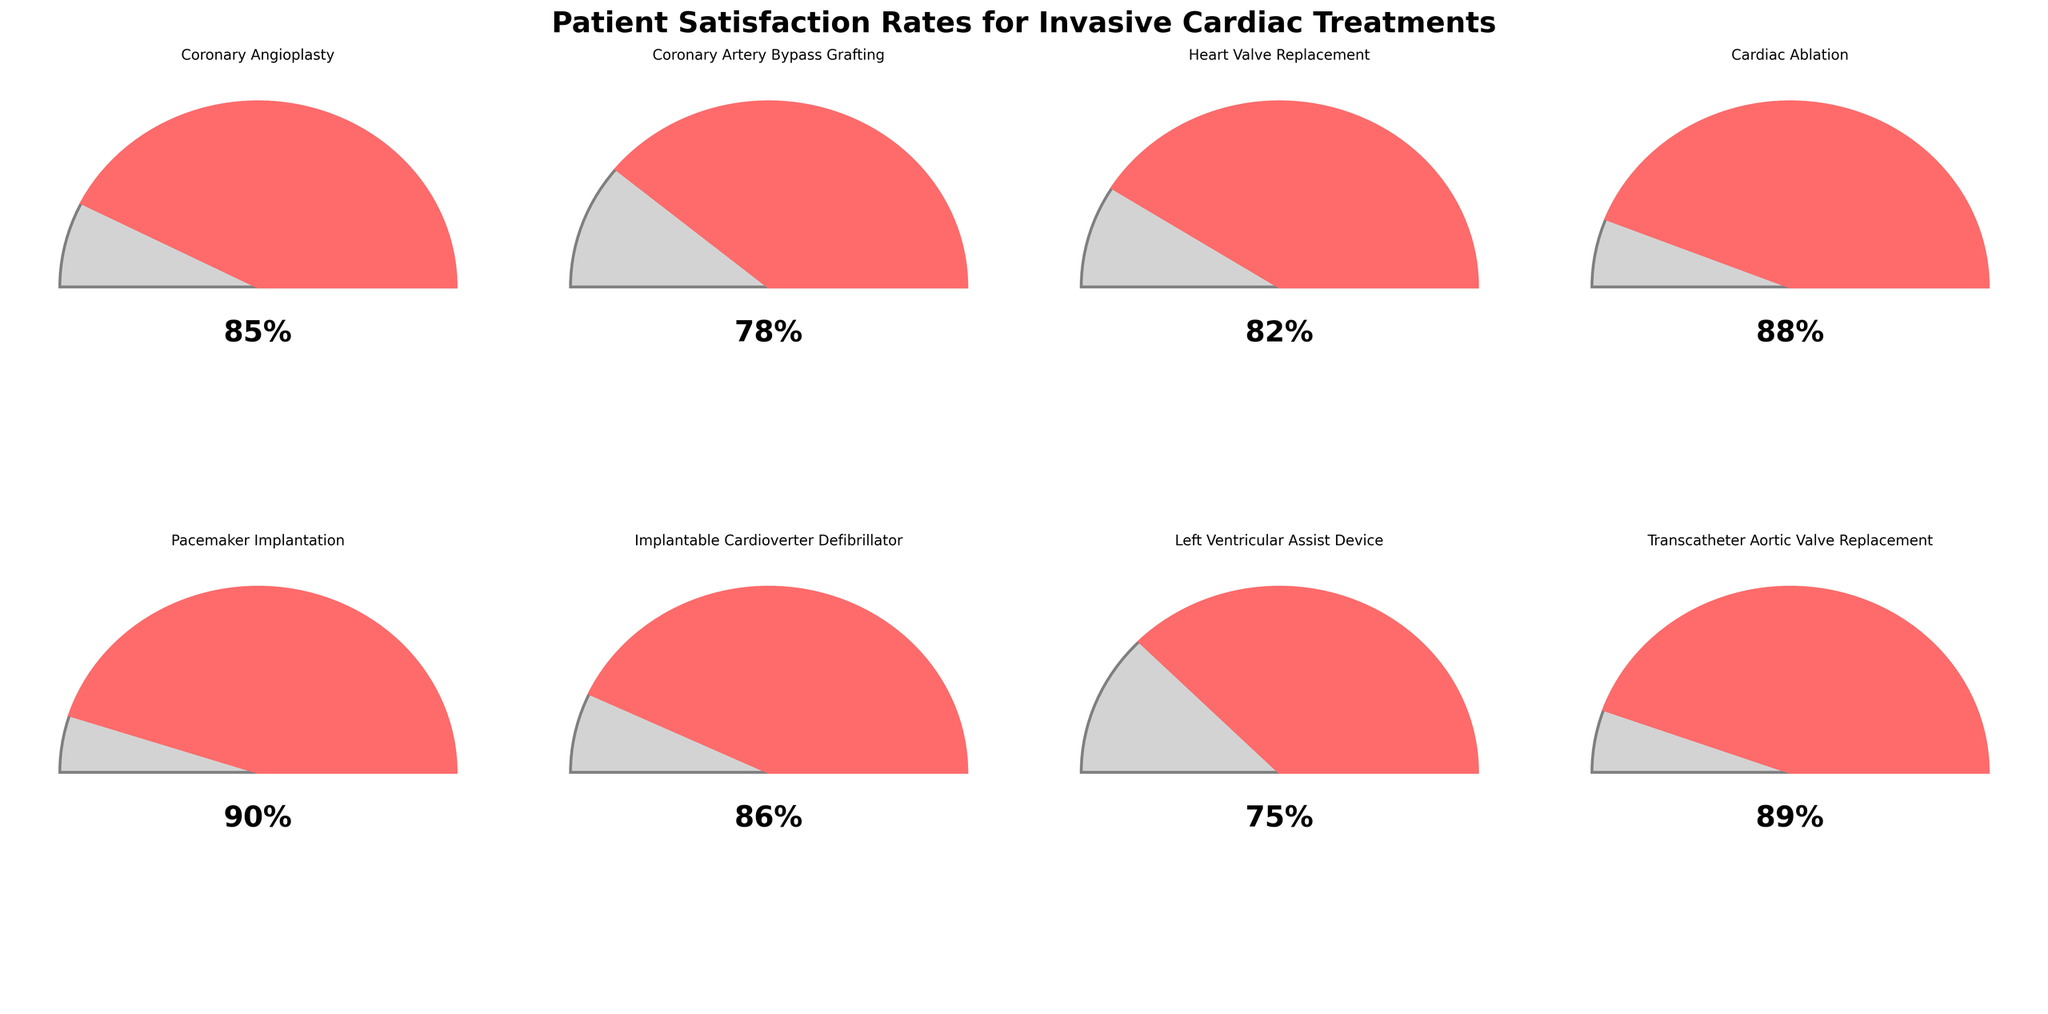What's the title of the figure? The title is typically located at the top of the figure. In this case, it reads: "Patient Satisfaction Rates for Invasive Cardiac Treatments".
Answer: Patient Satisfaction Rates for Invasive Cardiac Treatments How many treatments are displayed in the figure? To determine this, count the number of gauge charts in the figure. There are 8 treatments listed in the data, so the same should appear in the figure.
Answer: 8 Which treatment has the highest patient satisfaction rate? By comparing all the satisfaction rates in the gauge charts, "Pacemaker Implantation" shows the highest rate of 90%.
Answer: Pacemaker Implantation What is the patient satisfaction rate for Cardiac Ablation? Locate the gauge chart for "Cardiac Ablation" and identify the satisfaction rate presented on it. The rate displayed is 88%.
Answer: 88% Identify the treatment with the second-lowest patient satisfaction rate. After finding the rates for all treatments, excluding the lowest (Left Ventricular Assist Device at 75%), the second-lowest is "Coronary Artery Bypass Grafting" at 78%.
Answer: Coronary Artery Bypass Grafting What is the average patient satisfaction rate across all treatments? Sum all the satisfaction rates (85 + 78 + 82 + 88 + 90 + 86 + 75 + 89) and divide by the number of treatments (8). The total is 673, therefore the average is 673/8.
Answer: 84.125 Compare the patient satisfaction rates of "Coronary Angioplasty" and "Heart Valve Replacement." Which one is higher and by how much? "Coronary Angioplasty" has a satisfaction rate of 85%, while "Heart Valve Replacement" has 82%. The difference is 85 - 82.
Answer: Coronary Angioplasty by 3% Which treatment has a satisfaction rate closest to 85%? Analyzing the values, the treatments closest to 85% are "Coronary Angioplasty" at 85% and "Implantable Cardioverter Defibrillator" at 86%. The closest is "Coronary Angioplasty" directly at 85%.
Answer: Coronary Angioplasty Is there any treatment with a satisfaction rate below 80%? Reviewing the satisfaction rates, "Left Ventricular Assist Device" shows a rate of 75%, which is below 80%.
Answer: Yes (Left Ventricular Assist Device) List the treatments with satisfaction rates above 85%. From the data, the treatments with satisfaction rates above 85% are: "Cardiac Ablation" (88%), "Pacemaker Implantation" (90%), "Implantable Cardioverter Defibrillator" (86%), and "Transcatheter Aortic Valve Replacement" (89%).
Answer: Cardiac Ablation, Pacemaker Implantation, Implantable Cardioverter Defibrillator, Transcatheter Aortic Valve Replacement 